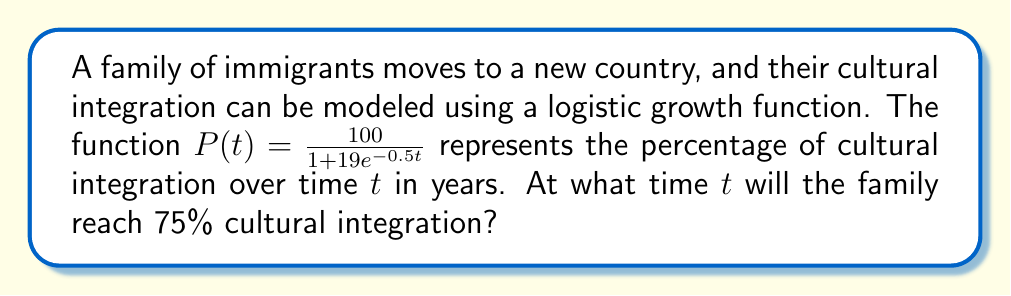Give your solution to this math problem. To solve this problem, we need to follow these steps:

1) We're given the logistic growth function:
   $P(t) = \frac{100}{1 + 19e^{-0.5t}}$

2) We want to find $t$ when $P(t) = 75$. So, let's set up the equation:
   $75 = \frac{100}{1 + 19e^{-0.5t}}$

3) Multiply both sides by $(1 + 19e^{-0.5t})$:
   $75(1 + 19e^{-0.5t}) = 100$

4) Distribute on the left side:
   $75 + 1425e^{-0.5t} = 100$

5) Subtract 75 from both sides:
   $1425e^{-0.5t} = 25$

6) Divide both sides by 1425:
   $e^{-0.5t} = \frac{25}{1425} = \frac{1}{57}$

7) Take the natural log of both sides:
   $-0.5t = \ln(\frac{1}{57})$

8) Divide both sides by -0.5:
   $t = -\frac{2}{1}\ln(\frac{1}{57}) = 2\ln(57)$

9) Calculate the final value:
   $t \approx 8.16$ years

Therefore, the family will reach 75% cultural integration after approximately 8.16 years.
Answer: $2\ln(57) \approx 8.16$ years 